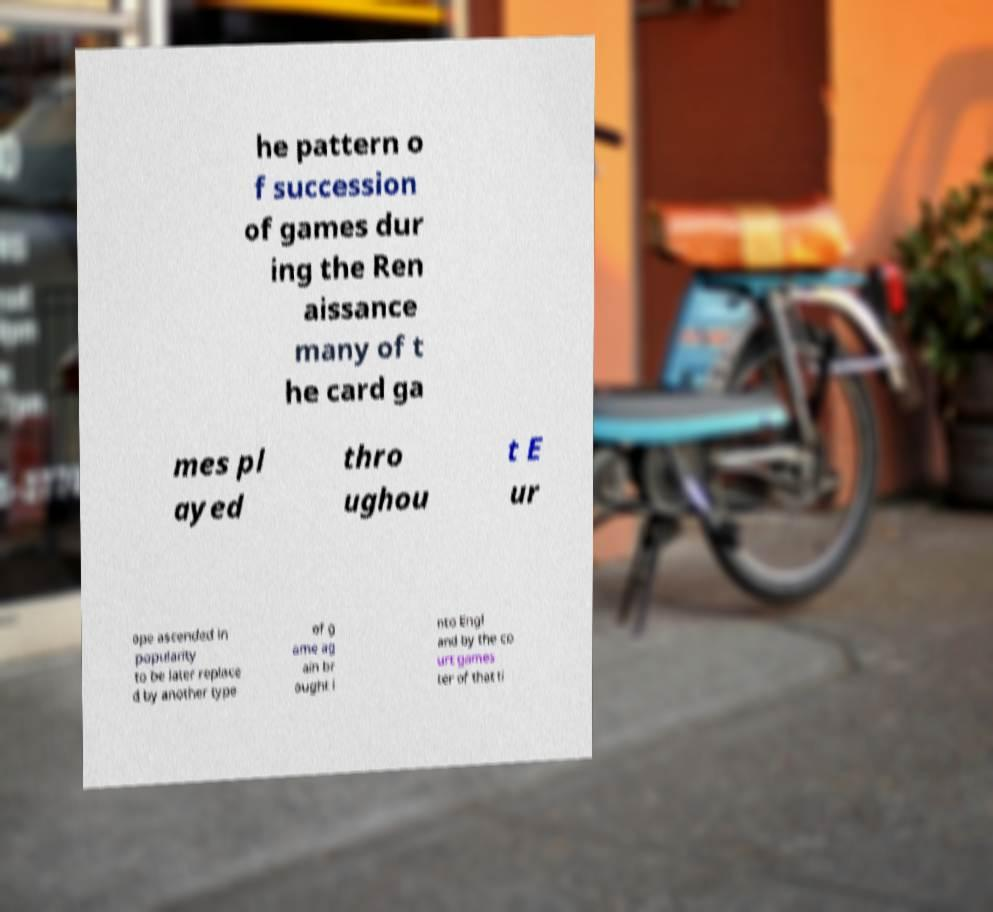Could you extract and type out the text from this image? he pattern o f succession of games dur ing the Ren aissance many of t he card ga mes pl ayed thro ughou t E ur ope ascended in popularity to be later replace d by another type of g ame ag ain br ought i nto Engl and by the co urt games ter of that ti 